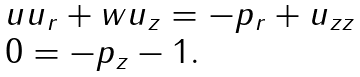Convert formula to latex. <formula><loc_0><loc_0><loc_500><loc_500>\begin{array} { l } u u _ { r } + w u _ { z } = - p _ { r } + u _ { z z } \\ 0 = - p _ { z } - 1 . \end{array}</formula> 